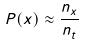Convert formula to latex. <formula><loc_0><loc_0><loc_500><loc_500>P ( x ) \approx \frac { n _ { x } } { n _ { t } }</formula> 